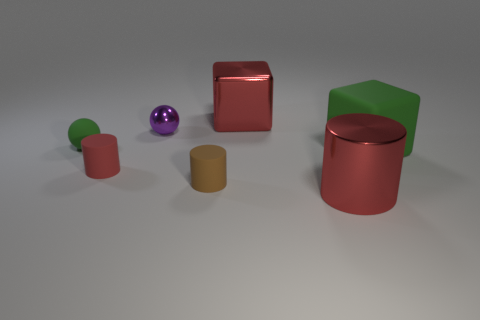Add 2 tiny cyan shiny cylinders. How many objects exist? 9 Subtract all blocks. How many objects are left? 5 Add 2 red metal spheres. How many red metal spheres exist? 2 Subtract 0 gray cylinders. How many objects are left? 7 Subtract all small purple matte things. Subtract all tiny green rubber spheres. How many objects are left? 6 Add 6 brown things. How many brown things are left? 7 